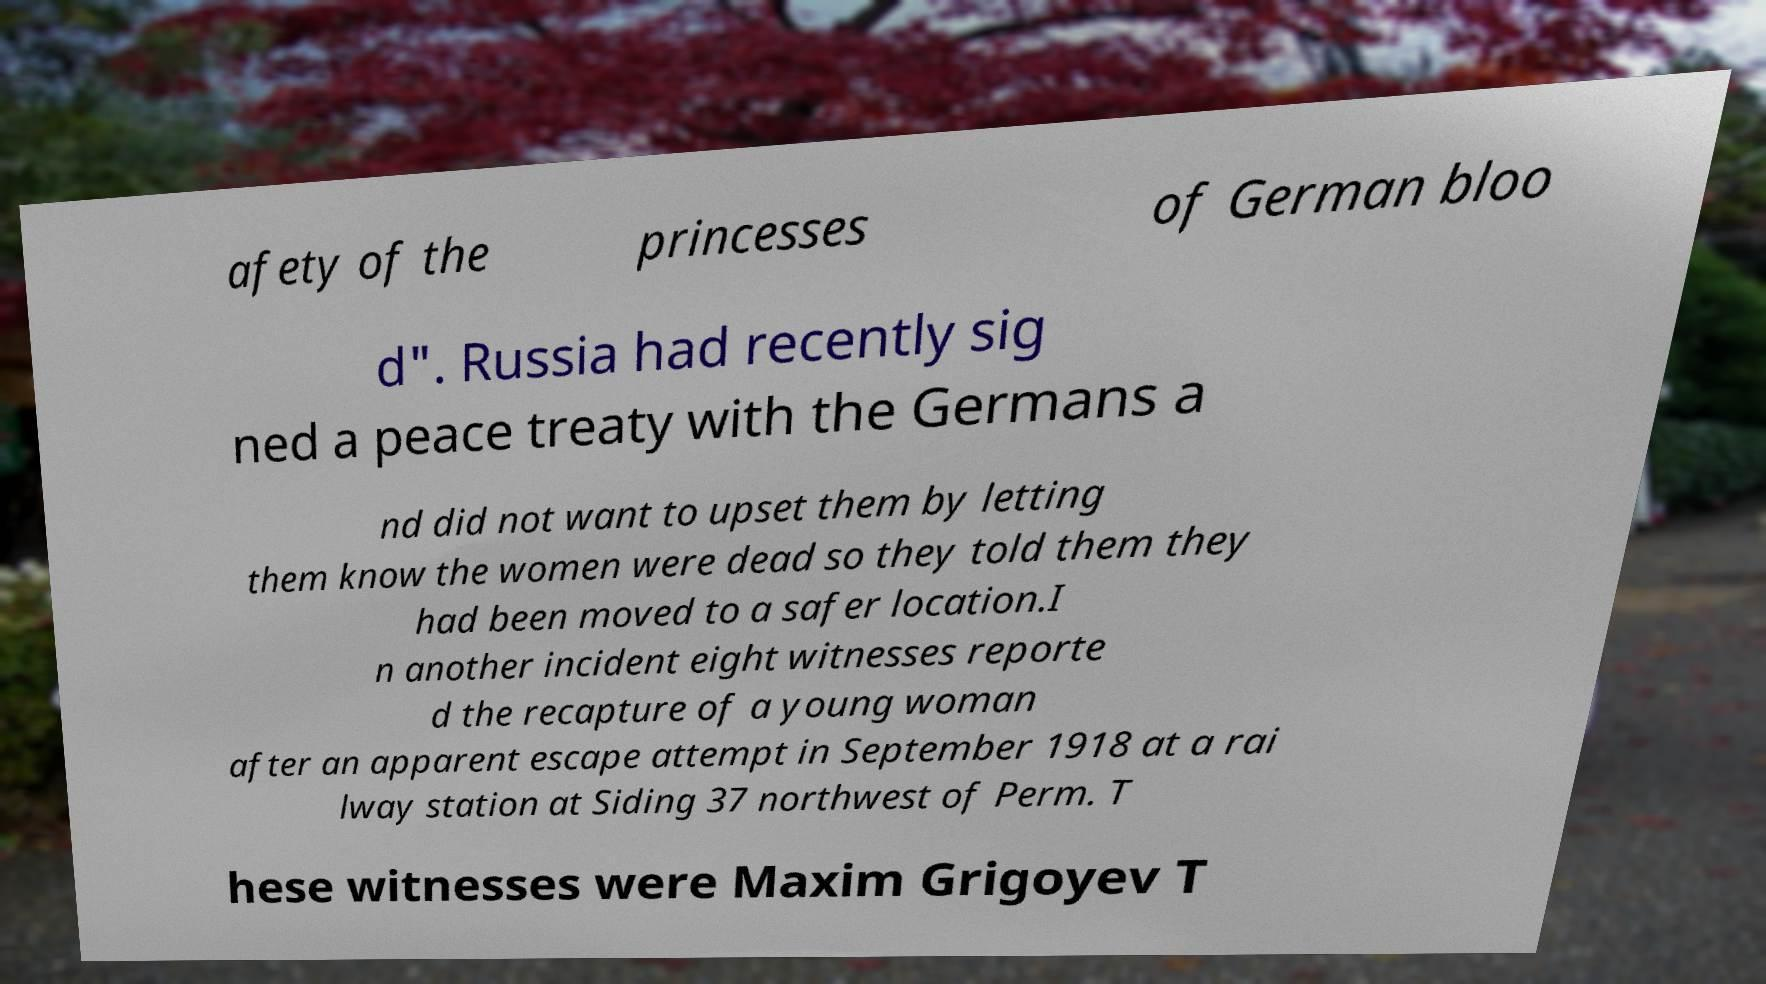What messages or text are displayed in this image? I need them in a readable, typed format. afety of the princesses of German bloo d". Russia had recently sig ned a peace treaty with the Germans a nd did not want to upset them by letting them know the women were dead so they told them they had been moved to a safer location.I n another incident eight witnesses reporte d the recapture of a young woman after an apparent escape attempt in September 1918 at a rai lway station at Siding 37 northwest of Perm. T hese witnesses were Maxim Grigoyev T 